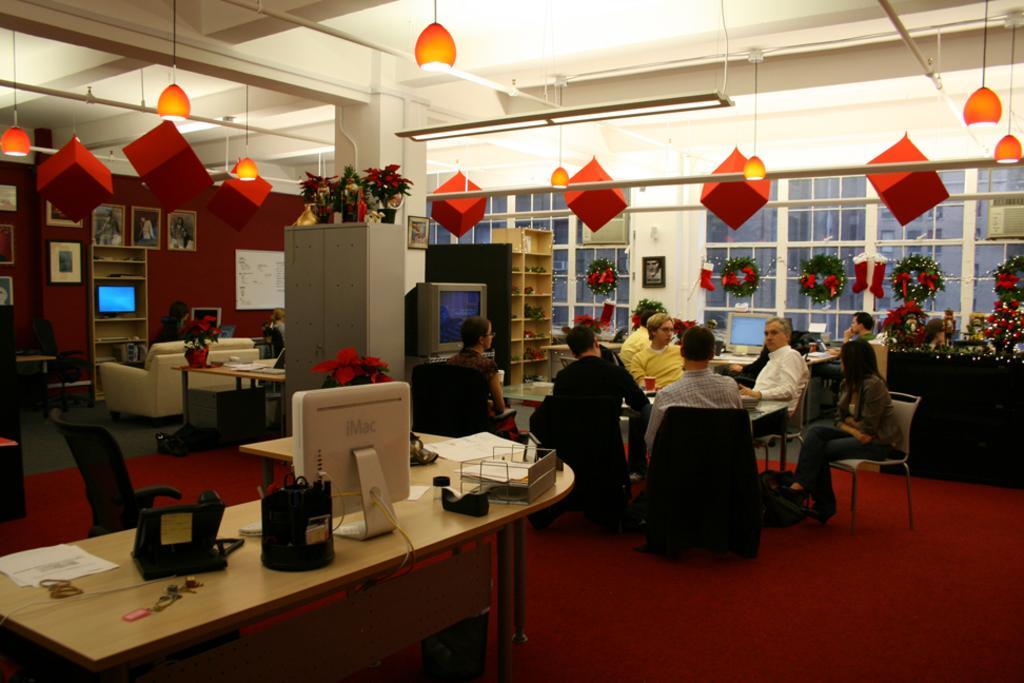Can you describe this image briefly? As we can see in the image there is a white color wall, windows, few people sitting over here and a table over here. On table there is a screen, plants and a red color floor. 